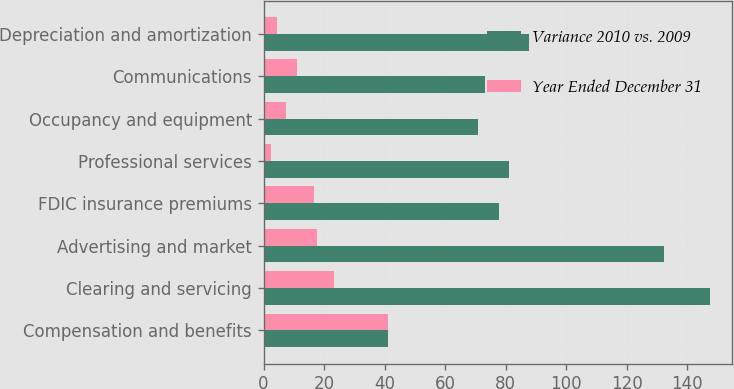Convert chart. <chart><loc_0><loc_0><loc_500><loc_500><stacked_bar_chart><ecel><fcel>Compensation and benefits<fcel>Clearing and servicing<fcel>Advertising and market<fcel>FDIC insurance premiums<fcel>Professional services<fcel>Occupancy and equipment<fcel>Communications<fcel>Depreciation and amortization<nl><fcel>Variance 2010 vs. 2009<fcel>41.2<fcel>147.5<fcel>132.2<fcel>77.7<fcel>81.2<fcel>70.9<fcel>73.3<fcel>87.9<nl><fcel>Year Ended December 31<fcel>41.2<fcel>23.2<fcel>17.8<fcel>16.6<fcel>2.5<fcel>7.5<fcel>11.1<fcel>4.6<nl></chart> 